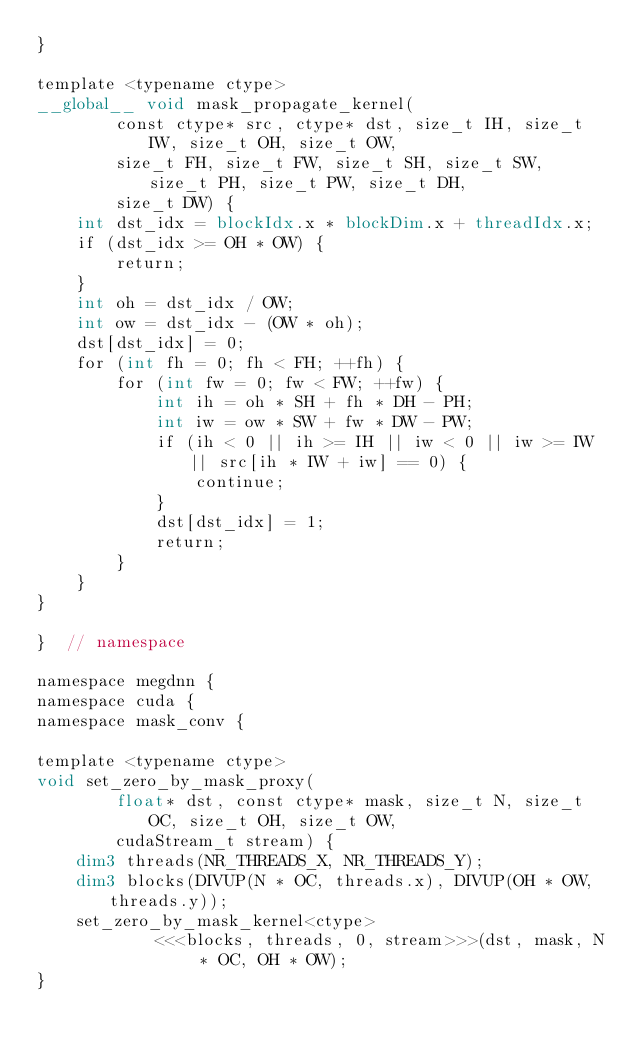Convert code to text. <code><loc_0><loc_0><loc_500><loc_500><_Cuda_>}

template <typename ctype>
__global__ void mask_propagate_kernel(
        const ctype* src, ctype* dst, size_t IH, size_t IW, size_t OH, size_t OW,
        size_t FH, size_t FW, size_t SH, size_t SW, size_t PH, size_t PW, size_t DH,
        size_t DW) {
    int dst_idx = blockIdx.x * blockDim.x + threadIdx.x;
    if (dst_idx >= OH * OW) {
        return;
    }
    int oh = dst_idx / OW;
    int ow = dst_idx - (OW * oh);
    dst[dst_idx] = 0;
    for (int fh = 0; fh < FH; ++fh) {
        for (int fw = 0; fw < FW; ++fw) {
            int ih = oh * SH + fh * DH - PH;
            int iw = ow * SW + fw * DW - PW;
            if (ih < 0 || ih >= IH || iw < 0 || iw >= IW || src[ih * IW + iw] == 0) {
                continue;
            }
            dst[dst_idx] = 1;
            return;
        }
    }
}

}  // namespace

namespace megdnn {
namespace cuda {
namespace mask_conv {

template <typename ctype>
void set_zero_by_mask_proxy(
        float* dst, const ctype* mask, size_t N, size_t OC, size_t OH, size_t OW,
        cudaStream_t stream) {
    dim3 threads(NR_THREADS_X, NR_THREADS_Y);
    dim3 blocks(DIVUP(N * OC, threads.x), DIVUP(OH * OW, threads.y));
    set_zero_by_mask_kernel<ctype>
            <<<blocks, threads, 0, stream>>>(dst, mask, N * OC, OH * OW);
}
</code> 